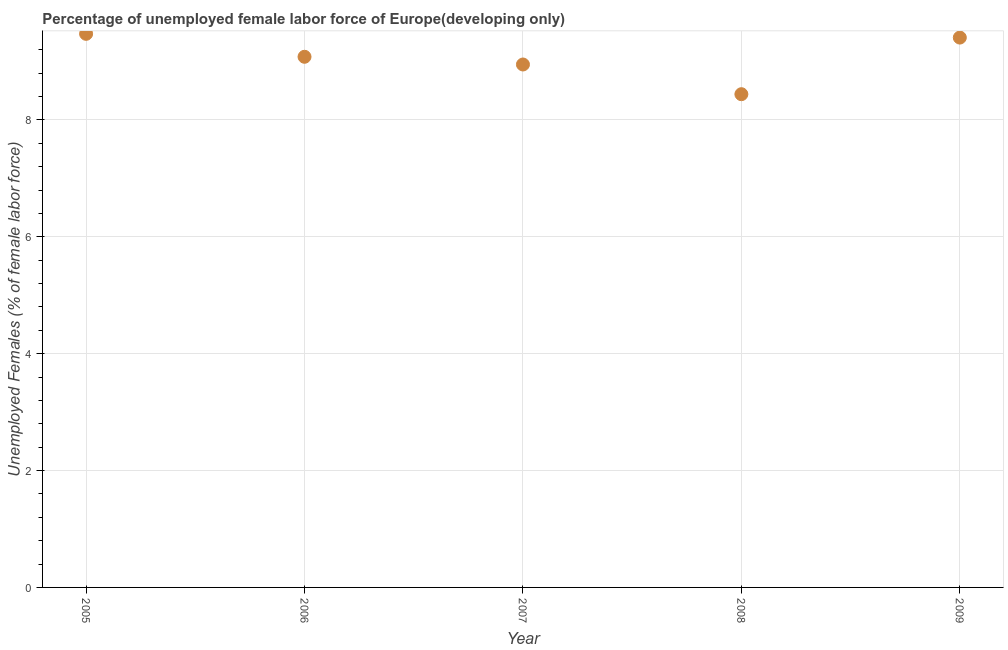What is the total unemployed female labour force in 2006?
Provide a succinct answer. 9.08. Across all years, what is the maximum total unemployed female labour force?
Keep it short and to the point. 9.47. Across all years, what is the minimum total unemployed female labour force?
Make the answer very short. 8.44. In which year was the total unemployed female labour force minimum?
Provide a succinct answer. 2008. What is the sum of the total unemployed female labour force?
Keep it short and to the point. 45.36. What is the difference between the total unemployed female labour force in 2008 and 2009?
Your answer should be very brief. -0.97. What is the average total unemployed female labour force per year?
Provide a short and direct response. 9.07. What is the median total unemployed female labour force?
Offer a terse response. 9.08. Do a majority of the years between 2009 and 2008 (inclusive) have total unemployed female labour force greater than 8 %?
Offer a very short reply. No. What is the ratio of the total unemployed female labour force in 2005 to that in 2008?
Your answer should be very brief. 1.12. What is the difference between the highest and the second highest total unemployed female labour force?
Ensure brevity in your answer.  0.06. Is the sum of the total unemployed female labour force in 2005 and 2009 greater than the maximum total unemployed female labour force across all years?
Keep it short and to the point. Yes. What is the difference between the highest and the lowest total unemployed female labour force?
Your answer should be very brief. 1.03. In how many years, is the total unemployed female labour force greater than the average total unemployed female labour force taken over all years?
Give a very brief answer. 3. How many years are there in the graph?
Provide a succinct answer. 5. What is the difference between two consecutive major ticks on the Y-axis?
Your response must be concise. 2. Are the values on the major ticks of Y-axis written in scientific E-notation?
Provide a short and direct response. No. Does the graph contain grids?
Provide a short and direct response. Yes. What is the title of the graph?
Offer a terse response. Percentage of unemployed female labor force of Europe(developing only). What is the label or title of the X-axis?
Give a very brief answer. Year. What is the label or title of the Y-axis?
Provide a short and direct response. Unemployed Females (% of female labor force). What is the Unemployed Females (% of female labor force) in 2005?
Ensure brevity in your answer.  9.47. What is the Unemployed Females (% of female labor force) in 2006?
Make the answer very short. 9.08. What is the Unemployed Females (% of female labor force) in 2007?
Offer a terse response. 8.95. What is the Unemployed Females (% of female labor force) in 2008?
Offer a terse response. 8.44. What is the Unemployed Females (% of female labor force) in 2009?
Provide a succinct answer. 9.41. What is the difference between the Unemployed Females (% of female labor force) in 2005 and 2006?
Ensure brevity in your answer.  0.39. What is the difference between the Unemployed Females (% of female labor force) in 2005 and 2007?
Provide a short and direct response. 0.52. What is the difference between the Unemployed Females (% of female labor force) in 2005 and 2008?
Offer a terse response. 1.03. What is the difference between the Unemployed Females (% of female labor force) in 2005 and 2009?
Give a very brief answer. 0.06. What is the difference between the Unemployed Females (% of female labor force) in 2006 and 2007?
Offer a terse response. 0.13. What is the difference between the Unemployed Females (% of female labor force) in 2006 and 2008?
Your answer should be very brief. 0.64. What is the difference between the Unemployed Females (% of female labor force) in 2006 and 2009?
Offer a terse response. -0.33. What is the difference between the Unemployed Females (% of female labor force) in 2007 and 2008?
Provide a succinct answer. 0.51. What is the difference between the Unemployed Females (% of female labor force) in 2007 and 2009?
Your response must be concise. -0.46. What is the difference between the Unemployed Females (% of female labor force) in 2008 and 2009?
Your answer should be compact. -0.97. What is the ratio of the Unemployed Females (% of female labor force) in 2005 to that in 2006?
Offer a very short reply. 1.04. What is the ratio of the Unemployed Females (% of female labor force) in 2005 to that in 2007?
Your answer should be compact. 1.06. What is the ratio of the Unemployed Females (% of female labor force) in 2005 to that in 2008?
Ensure brevity in your answer.  1.12. What is the ratio of the Unemployed Females (% of female labor force) in 2005 to that in 2009?
Ensure brevity in your answer.  1.01. What is the ratio of the Unemployed Females (% of female labor force) in 2006 to that in 2008?
Offer a very short reply. 1.08. What is the ratio of the Unemployed Females (% of female labor force) in 2006 to that in 2009?
Ensure brevity in your answer.  0.96. What is the ratio of the Unemployed Females (% of female labor force) in 2007 to that in 2008?
Make the answer very short. 1.06. What is the ratio of the Unemployed Females (% of female labor force) in 2007 to that in 2009?
Your response must be concise. 0.95. What is the ratio of the Unemployed Females (% of female labor force) in 2008 to that in 2009?
Keep it short and to the point. 0.9. 